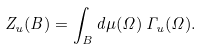<formula> <loc_0><loc_0><loc_500><loc_500>Z _ { u } ( B ) = \int _ { B } d \mu ( \Omega ) \, \Gamma _ { u } ( \Omega ) .</formula> 